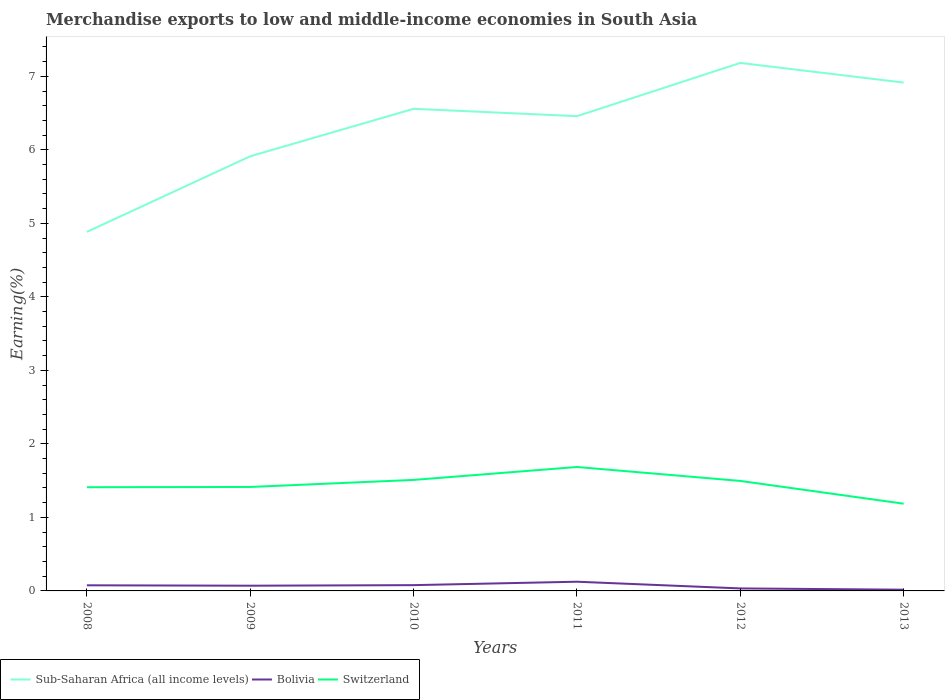Does the line corresponding to Sub-Saharan Africa (all income levels) intersect with the line corresponding to Switzerland?
Provide a short and direct response. No. Across all years, what is the maximum percentage of amount earned from merchandise exports in Bolivia?
Offer a very short reply. 0.02. In which year was the percentage of amount earned from merchandise exports in Sub-Saharan Africa (all income levels) maximum?
Keep it short and to the point. 2008. What is the total percentage of amount earned from merchandise exports in Bolivia in the graph?
Provide a succinct answer. 0.09. What is the difference between the highest and the second highest percentage of amount earned from merchandise exports in Switzerland?
Offer a very short reply. 0.5. What is the difference between the highest and the lowest percentage of amount earned from merchandise exports in Sub-Saharan Africa (all income levels)?
Provide a short and direct response. 4. Is the percentage of amount earned from merchandise exports in Switzerland strictly greater than the percentage of amount earned from merchandise exports in Sub-Saharan Africa (all income levels) over the years?
Your answer should be compact. Yes. How many lines are there?
Offer a terse response. 3. Does the graph contain any zero values?
Make the answer very short. No. How many legend labels are there?
Ensure brevity in your answer.  3. What is the title of the graph?
Offer a very short reply. Merchandise exports to low and middle-income economies in South Asia. Does "Vietnam" appear as one of the legend labels in the graph?
Offer a terse response. No. What is the label or title of the Y-axis?
Ensure brevity in your answer.  Earning(%). What is the Earning(%) of Sub-Saharan Africa (all income levels) in 2008?
Keep it short and to the point. 4.88. What is the Earning(%) of Bolivia in 2008?
Offer a very short reply. 0.08. What is the Earning(%) in Switzerland in 2008?
Make the answer very short. 1.41. What is the Earning(%) in Sub-Saharan Africa (all income levels) in 2009?
Your answer should be very brief. 5.91. What is the Earning(%) of Bolivia in 2009?
Make the answer very short. 0.07. What is the Earning(%) in Switzerland in 2009?
Make the answer very short. 1.41. What is the Earning(%) in Sub-Saharan Africa (all income levels) in 2010?
Make the answer very short. 6.56. What is the Earning(%) in Bolivia in 2010?
Provide a succinct answer. 0.08. What is the Earning(%) in Switzerland in 2010?
Make the answer very short. 1.51. What is the Earning(%) in Sub-Saharan Africa (all income levels) in 2011?
Offer a terse response. 6.46. What is the Earning(%) of Bolivia in 2011?
Ensure brevity in your answer.  0.13. What is the Earning(%) of Switzerland in 2011?
Your answer should be very brief. 1.69. What is the Earning(%) in Sub-Saharan Africa (all income levels) in 2012?
Your response must be concise. 7.18. What is the Earning(%) of Bolivia in 2012?
Offer a very short reply. 0.03. What is the Earning(%) in Switzerland in 2012?
Your response must be concise. 1.5. What is the Earning(%) in Sub-Saharan Africa (all income levels) in 2013?
Your response must be concise. 6.91. What is the Earning(%) in Bolivia in 2013?
Make the answer very short. 0.02. What is the Earning(%) of Switzerland in 2013?
Give a very brief answer. 1.19. Across all years, what is the maximum Earning(%) in Sub-Saharan Africa (all income levels)?
Make the answer very short. 7.18. Across all years, what is the maximum Earning(%) in Bolivia?
Ensure brevity in your answer.  0.13. Across all years, what is the maximum Earning(%) of Switzerland?
Your answer should be very brief. 1.69. Across all years, what is the minimum Earning(%) of Sub-Saharan Africa (all income levels)?
Make the answer very short. 4.88. Across all years, what is the minimum Earning(%) in Bolivia?
Provide a succinct answer. 0.02. Across all years, what is the minimum Earning(%) of Switzerland?
Ensure brevity in your answer.  1.19. What is the total Earning(%) of Sub-Saharan Africa (all income levels) in the graph?
Offer a very short reply. 37.91. What is the total Earning(%) of Bolivia in the graph?
Your answer should be very brief. 0.4. What is the total Earning(%) of Switzerland in the graph?
Offer a very short reply. 8.7. What is the difference between the Earning(%) of Sub-Saharan Africa (all income levels) in 2008 and that in 2009?
Provide a succinct answer. -1.03. What is the difference between the Earning(%) of Bolivia in 2008 and that in 2009?
Your answer should be very brief. 0.01. What is the difference between the Earning(%) of Switzerland in 2008 and that in 2009?
Your answer should be very brief. -0. What is the difference between the Earning(%) in Sub-Saharan Africa (all income levels) in 2008 and that in 2010?
Offer a terse response. -1.67. What is the difference between the Earning(%) in Bolivia in 2008 and that in 2010?
Give a very brief answer. -0. What is the difference between the Earning(%) in Switzerland in 2008 and that in 2010?
Make the answer very short. -0.1. What is the difference between the Earning(%) of Sub-Saharan Africa (all income levels) in 2008 and that in 2011?
Provide a succinct answer. -1.57. What is the difference between the Earning(%) in Bolivia in 2008 and that in 2011?
Make the answer very short. -0.05. What is the difference between the Earning(%) in Switzerland in 2008 and that in 2011?
Provide a succinct answer. -0.28. What is the difference between the Earning(%) in Sub-Saharan Africa (all income levels) in 2008 and that in 2012?
Keep it short and to the point. -2.3. What is the difference between the Earning(%) in Bolivia in 2008 and that in 2012?
Offer a very short reply. 0.04. What is the difference between the Earning(%) in Switzerland in 2008 and that in 2012?
Ensure brevity in your answer.  -0.09. What is the difference between the Earning(%) in Sub-Saharan Africa (all income levels) in 2008 and that in 2013?
Keep it short and to the point. -2.03. What is the difference between the Earning(%) of Bolivia in 2008 and that in 2013?
Make the answer very short. 0.06. What is the difference between the Earning(%) in Switzerland in 2008 and that in 2013?
Give a very brief answer. 0.22. What is the difference between the Earning(%) in Sub-Saharan Africa (all income levels) in 2009 and that in 2010?
Your response must be concise. -0.65. What is the difference between the Earning(%) of Bolivia in 2009 and that in 2010?
Provide a short and direct response. -0.01. What is the difference between the Earning(%) in Switzerland in 2009 and that in 2010?
Offer a terse response. -0.1. What is the difference between the Earning(%) in Sub-Saharan Africa (all income levels) in 2009 and that in 2011?
Ensure brevity in your answer.  -0.55. What is the difference between the Earning(%) in Bolivia in 2009 and that in 2011?
Make the answer very short. -0.05. What is the difference between the Earning(%) in Switzerland in 2009 and that in 2011?
Your answer should be compact. -0.27. What is the difference between the Earning(%) of Sub-Saharan Africa (all income levels) in 2009 and that in 2012?
Offer a very short reply. -1.27. What is the difference between the Earning(%) in Bolivia in 2009 and that in 2012?
Ensure brevity in your answer.  0.04. What is the difference between the Earning(%) of Switzerland in 2009 and that in 2012?
Offer a terse response. -0.08. What is the difference between the Earning(%) in Sub-Saharan Africa (all income levels) in 2009 and that in 2013?
Provide a succinct answer. -1. What is the difference between the Earning(%) in Bolivia in 2009 and that in 2013?
Ensure brevity in your answer.  0.05. What is the difference between the Earning(%) of Switzerland in 2009 and that in 2013?
Provide a succinct answer. 0.23. What is the difference between the Earning(%) of Sub-Saharan Africa (all income levels) in 2010 and that in 2011?
Make the answer very short. 0.1. What is the difference between the Earning(%) of Bolivia in 2010 and that in 2011?
Keep it short and to the point. -0.05. What is the difference between the Earning(%) of Switzerland in 2010 and that in 2011?
Provide a succinct answer. -0.18. What is the difference between the Earning(%) in Sub-Saharan Africa (all income levels) in 2010 and that in 2012?
Your answer should be very brief. -0.62. What is the difference between the Earning(%) of Bolivia in 2010 and that in 2012?
Offer a terse response. 0.04. What is the difference between the Earning(%) in Switzerland in 2010 and that in 2012?
Provide a succinct answer. 0.01. What is the difference between the Earning(%) of Sub-Saharan Africa (all income levels) in 2010 and that in 2013?
Make the answer very short. -0.36. What is the difference between the Earning(%) in Bolivia in 2010 and that in 2013?
Your response must be concise. 0.06. What is the difference between the Earning(%) of Switzerland in 2010 and that in 2013?
Provide a succinct answer. 0.32. What is the difference between the Earning(%) of Sub-Saharan Africa (all income levels) in 2011 and that in 2012?
Make the answer very short. -0.72. What is the difference between the Earning(%) in Bolivia in 2011 and that in 2012?
Your response must be concise. 0.09. What is the difference between the Earning(%) of Switzerland in 2011 and that in 2012?
Give a very brief answer. 0.19. What is the difference between the Earning(%) in Sub-Saharan Africa (all income levels) in 2011 and that in 2013?
Your response must be concise. -0.46. What is the difference between the Earning(%) of Bolivia in 2011 and that in 2013?
Make the answer very short. 0.11. What is the difference between the Earning(%) in Switzerland in 2011 and that in 2013?
Your response must be concise. 0.5. What is the difference between the Earning(%) of Sub-Saharan Africa (all income levels) in 2012 and that in 2013?
Your answer should be compact. 0.27. What is the difference between the Earning(%) of Bolivia in 2012 and that in 2013?
Give a very brief answer. 0.02. What is the difference between the Earning(%) in Switzerland in 2012 and that in 2013?
Make the answer very short. 0.31. What is the difference between the Earning(%) of Sub-Saharan Africa (all income levels) in 2008 and the Earning(%) of Bolivia in 2009?
Your answer should be compact. 4.81. What is the difference between the Earning(%) in Sub-Saharan Africa (all income levels) in 2008 and the Earning(%) in Switzerland in 2009?
Make the answer very short. 3.47. What is the difference between the Earning(%) in Bolivia in 2008 and the Earning(%) in Switzerland in 2009?
Offer a terse response. -1.34. What is the difference between the Earning(%) of Sub-Saharan Africa (all income levels) in 2008 and the Earning(%) of Bolivia in 2010?
Make the answer very short. 4.81. What is the difference between the Earning(%) in Sub-Saharan Africa (all income levels) in 2008 and the Earning(%) in Switzerland in 2010?
Provide a short and direct response. 3.37. What is the difference between the Earning(%) of Bolivia in 2008 and the Earning(%) of Switzerland in 2010?
Offer a very short reply. -1.43. What is the difference between the Earning(%) of Sub-Saharan Africa (all income levels) in 2008 and the Earning(%) of Bolivia in 2011?
Keep it short and to the point. 4.76. What is the difference between the Earning(%) in Sub-Saharan Africa (all income levels) in 2008 and the Earning(%) in Switzerland in 2011?
Provide a short and direct response. 3.2. What is the difference between the Earning(%) in Bolivia in 2008 and the Earning(%) in Switzerland in 2011?
Provide a succinct answer. -1.61. What is the difference between the Earning(%) in Sub-Saharan Africa (all income levels) in 2008 and the Earning(%) in Bolivia in 2012?
Your response must be concise. 4.85. What is the difference between the Earning(%) of Sub-Saharan Africa (all income levels) in 2008 and the Earning(%) of Switzerland in 2012?
Make the answer very short. 3.39. What is the difference between the Earning(%) of Bolivia in 2008 and the Earning(%) of Switzerland in 2012?
Your answer should be compact. -1.42. What is the difference between the Earning(%) of Sub-Saharan Africa (all income levels) in 2008 and the Earning(%) of Bolivia in 2013?
Your answer should be very brief. 4.87. What is the difference between the Earning(%) of Sub-Saharan Africa (all income levels) in 2008 and the Earning(%) of Switzerland in 2013?
Ensure brevity in your answer.  3.7. What is the difference between the Earning(%) of Bolivia in 2008 and the Earning(%) of Switzerland in 2013?
Keep it short and to the point. -1.11. What is the difference between the Earning(%) in Sub-Saharan Africa (all income levels) in 2009 and the Earning(%) in Bolivia in 2010?
Your answer should be very brief. 5.83. What is the difference between the Earning(%) in Sub-Saharan Africa (all income levels) in 2009 and the Earning(%) in Switzerland in 2010?
Ensure brevity in your answer.  4.4. What is the difference between the Earning(%) of Bolivia in 2009 and the Earning(%) of Switzerland in 2010?
Your response must be concise. -1.44. What is the difference between the Earning(%) of Sub-Saharan Africa (all income levels) in 2009 and the Earning(%) of Bolivia in 2011?
Offer a very short reply. 5.79. What is the difference between the Earning(%) in Sub-Saharan Africa (all income levels) in 2009 and the Earning(%) in Switzerland in 2011?
Offer a terse response. 4.23. What is the difference between the Earning(%) of Bolivia in 2009 and the Earning(%) of Switzerland in 2011?
Your response must be concise. -1.61. What is the difference between the Earning(%) of Sub-Saharan Africa (all income levels) in 2009 and the Earning(%) of Bolivia in 2012?
Your answer should be compact. 5.88. What is the difference between the Earning(%) of Sub-Saharan Africa (all income levels) in 2009 and the Earning(%) of Switzerland in 2012?
Ensure brevity in your answer.  4.42. What is the difference between the Earning(%) of Bolivia in 2009 and the Earning(%) of Switzerland in 2012?
Ensure brevity in your answer.  -1.43. What is the difference between the Earning(%) in Sub-Saharan Africa (all income levels) in 2009 and the Earning(%) in Bolivia in 2013?
Your response must be concise. 5.9. What is the difference between the Earning(%) of Sub-Saharan Africa (all income levels) in 2009 and the Earning(%) of Switzerland in 2013?
Your response must be concise. 4.73. What is the difference between the Earning(%) of Bolivia in 2009 and the Earning(%) of Switzerland in 2013?
Give a very brief answer. -1.12. What is the difference between the Earning(%) of Sub-Saharan Africa (all income levels) in 2010 and the Earning(%) of Bolivia in 2011?
Your response must be concise. 6.43. What is the difference between the Earning(%) of Sub-Saharan Africa (all income levels) in 2010 and the Earning(%) of Switzerland in 2011?
Ensure brevity in your answer.  4.87. What is the difference between the Earning(%) of Bolivia in 2010 and the Earning(%) of Switzerland in 2011?
Your response must be concise. -1.61. What is the difference between the Earning(%) of Sub-Saharan Africa (all income levels) in 2010 and the Earning(%) of Bolivia in 2012?
Provide a succinct answer. 6.52. What is the difference between the Earning(%) of Sub-Saharan Africa (all income levels) in 2010 and the Earning(%) of Switzerland in 2012?
Your answer should be very brief. 5.06. What is the difference between the Earning(%) in Bolivia in 2010 and the Earning(%) in Switzerland in 2012?
Give a very brief answer. -1.42. What is the difference between the Earning(%) in Sub-Saharan Africa (all income levels) in 2010 and the Earning(%) in Bolivia in 2013?
Provide a short and direct response. 6.54. What is the difference between the Earning(%) of Sub-Saharan Africa (all income levels) in 2010 and the Earning(%) of Switzerland in 2013?
Your answer should be very brief. 5.37. What is the difference between the Earning(%) in Bolivia in 2010 and the Earning(%) in Switzerland in 2013?
Your response must be concise. -1.11. What is the difference between the Earning(%) in Sub-Saharan Africa (all income levels) in 2011 and the Earning(%) in Bolivia in 2012?
Give a very brief answer. 6.42. What is the difference between the Earning(%) of Sub-Saharan Africa (all income levels) in 2011 and the Earning(%) of Switzerland in 2012?
Your answer should be very brief. 4.96. What is the difference between the Earning(%) in Bolivia in 2011 and the Earning(%) in Switzerland in 2012?
Ensure brevity in your answer.  -1.37. What is the difference between the Earning(%) in Sub-Saharan Africa (all income levels) in 2011 and the Earning(%) in Bolivia in 2013?
Provide a succinct answer. 6.44. What is the difference between the Earning(%) in Sub-Saharan Africa (all income levels) in 2011 and the Earning(%) in Switzerland in 2013?
Your answer should be very brief. 5.27. What is the difference between the Earning(%) in Bolivia in 2011 and the Earning(%) in Switzerland in 2013?
Ensure brevity in your answer.  -1.06. What is the difference between the Earning(%) of Sub-Saharan Africa (all income levels) in 2012 and the Earning(%) of Bolivia in 2013?
Offer a terse response. 7.17. What is the difference between the Earning(%) in Sub-Saharan Africa (all income levels) in 2012 and the Earning(%) in Switzerland in 2013?
Ensure brevity in your answer.  6. What is the difference between the Earning(%) of Bolivia in 2012 and the Earning(%) of Switzerland in 2013?
Keep it short and to the point. -1.15. What is the average Earning(%) of Sub-Saharan Africa (all income levels) per year?
Ensure brevity in your answer.  6.32. What is the average Earning(%) in Bolivia per year?
Your response must be concise. 0.07. What is the average Earning(%) in Switzerland per year?
Your answer should be compact. 1.45. In the year 2008, what is the difference between the Earning(%) of Sub-Saharan Africa (all income levels) and Earning(%) of Bolivia?
Offer a very short reply. 4.81. In the year 2008, what is the difference between the Earning(%) in Sub-Saharan Africa (all income levels) and Earning(%) in Switzerland?
Make the answer very short. 3.47. In the year 2008, what is the difference between the Earning(%) of Bolivia and Earning(%) of Switzerland?
Provide a succinct answer. -1.33. In the year 2009, what is the difference between the Earning(%) of Sub-Saharan Africa (all income levels) and Earning(%) of Bolivia?
Your response must be concise. 5.84. In the year 2009, what is the difference between the Earning(%) in Sub-Saharan Africa (all income levels) and Earning(%) in Switzerland?
Keep it short and to the point. 4.5. In the year 2009, what is the difference between the Earning(%) of Bolivia and Earning(%) of Switzerland?
Ensure brevity in your answer.  -1.34. In the year 2010, what is the difference between the Earning(%) of Sub-Saharan Africa (all income levels) and Earning(%) of Bolivia?
Give a very brief answer. 6.48. In the year 2010, what is the difference between the Earning(%) of Sub-Saharan Africa (all income levels) and Earning(%) of Switzerland?
Offer a terse response. 5.05. In the year 2010, what is the difference between the Earning(%) in Bolivia and Earning(%) in Switzerland?
Offer a terse response. -1.43. In the year 2011, what is the difference between the Earning(%) in Sub-Saharan Africa (all income levels) and Earning(%) in Bolivia?
Offer a very short reply. 6.33. In the year 2011, what is the difference between the Earning(%) of Sub-Saharan Africa (all income levels) and Earning(%) of Switzerland?
Provide a short and direct response. 4.77. In the year 2011, what is the difference between the Earning(%) in Bolivia and Earning(%) in Switzerland?
Offer a terse response. -1.56. In the year 2012, what is the difference between the Earning(%) in Sub-Saharan Africa (all income levels) and Earning(%) in Bolivia?
Make the answer very short. 7.15. In the year 2012, what is the difference between the Earning(%) of Sub-Saharan Africa (all income levels) and Earning(%) of Switzerland?
Ensure brevity in your answer.  5.69. In the year 2012, what is the difference between the Earning(%) of Bolivia and Earning(%) of Switzerland?
Provide a succinct answer. -1.46. In the year 2013, what is the difference between the Earning(%) of Sub-Saharan Africa (all income levels) and Earning(%) of Bolivia?
Offer a terse response. 6.9. In the year 2013, what is the difference between the Earning(%) of Sub-Saharan Africa (all income levels) and Earning(%) of Switzerland?
Your answer should be compact. 5.73. In the year 2013, what is the difference between the Earning(%) of Bolivia and Earning(%) of Switzerland?
Keep it short and to the point. -1.17. What is the ratio of the Earning(%) of Sub-Saharan Africa (all income levels) in 2008 to that in 2009?
Make the answer very short. 0.83. What is the ratio of the Earning(%) in Bolivia in 2008 to that in 2009?
Your answer should be very brief. 1.08. What is the ratio of the Earning(%) in Switzerland in 2008 to that in 2009?
Make the answer very short. 1. What is the ratio of the Earning(%) of Sub-Saharan Africa (all income levels) in 2008 to that in 2010?
Your answer should be compact. 0.74. What is the ratio of the Earning(%) in Bolivia in 2008 to that in 2010?
Your response must be concise. 0.97. What is the ratio of the Earning(%) of Switzerland in 2008 to that in 2010?
Your answer should be very brief. 0.93. What is the ratio of the Earning(%) in Sub-Saharan Africa (all income levels) in 2008 to that in 2011?
Your answer should be compact. 0.76. What is the ratio of the Earning(%) in Bolivia in 2008 to that in 2011?
Offer a very short reply. 0.61. What is the ratio of the Earning(%) of Switzerland in 2008 to that in 2011?
Your answer should be very brief. 0.84. What is the ratio of the Earning(%) of Sub-Saharan Africa (all income levels) in 2008 to that in 2012?
Your answer should be compact. 0.68. What is the ratio of the Earning(%) in Bolivia in 2008 to that in 2012?
Keep it short and to the point. 2.25. What is the ratio of the Earning(%) of Switzerland in 2008 to that in 2012?
Your response must be concise. 0.94. What is the ratio of the Earning(%) in Sub-Saharan Africa (all income levels) in 2008 to that in 2013?
Provide a succinct answer. 0.71. What is the ratio of the Earning(%) in Bolivia in 2008 to that in 2013?
Provide a short and direct response. 4.57. What is the ratio of the Earning(%) in Switzerland in 2008 to that in 2013?
Your response must be concise. 1.19. What is the ratio of the Earning(%) of Sub-Saharan Africa (all income levels) in 2009 to that in 2010?
Your answer should be compact. 0.9. What is the ratio of the Earning(%) in Bolivia in 2009 to that in 2010?
Give a very brief answer. 0.9. What is the ratio of the Earning(%) of Switzerland in 2009 to that in 2010?
Your response must be concise. 0.94. What is the ratio of the Earning(%) of Sub-Saharan Africa (all income levels) in 2009 to that in 2011?
Keep it short and to the point. 0.92. What is the ratio of the Earning(%) of Bolivia in 2009 to that in 2011?
Your answer should be compact. 0.57. What is the ratio of the Earning(%) in Switzerland in 2009 to that in 2011?
Your answer should be very brief. 0.84. What is the ratio of the Earning(%) of Sub-Saharan Africa (all income levels) in 2009 to that in 2012?
Ensure brevity in your answer.  0.82. What is the ratio of the Earning(%) in Bolivia in 2009 to that in 2012?
Give a very brief answer. 2.08. What is the ratio of the Earning(%) of Switzerland in 2009 to that in 2012?
Ensure brevity in your answer.  0.94. What is the ratio of the Earning(%) of Sub-Saharan Africa (all income levels) in 2009 to that in 2013?
Offer a very short reply. 0.85. What is the ratio of the Earning(%) in Bolivia in 2009 to that in 2013?
Give a very brief answer. 4.24. What is the ratio of the Earning(%) of Switzerland in 2009 to that in 2013?
Your answer should be compact. 1.19. What is the ratio of the Earning(%) of Sub-Saharan Africa (all income levels) in 2010 to that in 2011?
Ensure brevity in your answer.  1.02. What is the ratio of the Earning(%) of Bolivia in 2010 to that in 2011?
Provide a succinct answer. 0.63. What is the ratio of the Earning(%) of Switzerland in 2010 to that in 2011?
Offer a terse response. 0.9. What is the ratio of the Earning(%) of Sub-Saharan Africa (all income levels) in 2010 to that in 2012?
Ensure brevity in your answer.  0.91. What is the ratio of the Earning(%) of Bolivia in 2010 to that in 2012?
Make the answer very short. 2.31. What is the ratio of the Earning(%) of Switzerland in 2010 to that in 2012?
Ensure brevity in your answer.  1.01. What is the ratio of the Earning(%) in Sub-Saharan Africa (all income levels) in 2010 to that in 2013?
Offer a very short reply. 0.95. What is the ratio of the Earning(%) in Bolivia in 2010 to that in 2013?
Give a very brief answer. 4.69. What is the ratio of the Earning(%) of Switzerland in 2010 to that in 2013?
Give a very brief answer. 1.27. What is the ratio of the Earning(%) of Sub-Saharan Africa (all income levels) in 2011 to that in 2012?
Make the answer very short. 0.9. What is the ratio of the Earning(%) in Bolivia in 2011 to that in 2012?
Keep it short and to the point. 3.67. What is the ratio of the Earning(%) of Switzerland in 2011 to that in 2012?
Provide a short and direct response. 1.13. What is the ratio of the Earning(%) of Sub-Saharan Africa (all income levels) in 2011 to that in 2013?
Offer a terse response. 0.93. What is the ratio of the Earning(%) in Bolivia in 2011 to that in 2013?
Offer a very short reply. 7.48. What is the ratio of the Earning(%) in Switzerland in 2011 to that in 2013?
Your response must be concise. 1.42. What is the ratio of the Earning(%) in Sub-Saharan Africa (all income levels) in 2012 to that in 2013?
Offer a very short reply. 1.04. What is the ratio of the Earning(%) in Bolivia in 2012 to that in 2013?
Make the answer very short. 2.03. What is the ratio of the Earning(%) of Switzerland in 2012 to that in 2013?
Your response must be concise. 1.26. What is the difference between the highest and the second highest Earning(%) of Sub-Saharan Africa (all income levels)?
Provide a short and direct response. 0.27. What is the difference between the highest and the second highest Earning(%) in Bolivia?
Make the answer very short. 0.05. What is the difference between the highest and the second highest Earning(%) in Switzerland?
Make the answer very short. 0.18. What is the difference between the highest and the lowest Earning(%) in Sub-Saharan Africa (all income levels)?
Your response must be concise. 2.3. What is the difference between the highest and the lowest Earning(%) of Bolivia?
Your answer should be compact. 0.11. What is the difference between the highest and the lowest Earning(%) in Switzerland?
Your answer should be very brief. 0.5. 